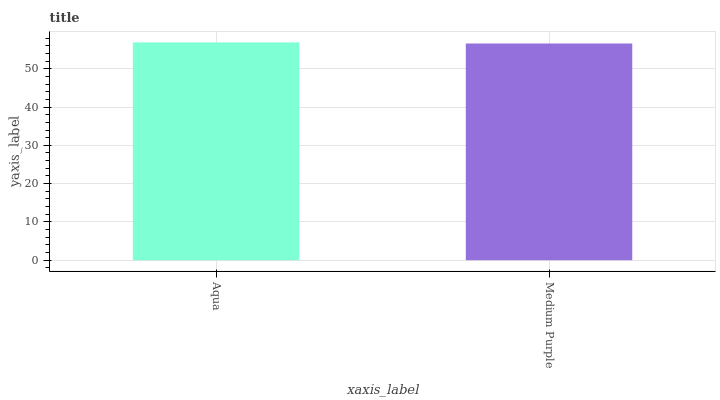Is Medium Purple the minimum?
Answer yes or no. Yes. Is Aqua the maximum?
Answer yes or no. Yes. Is Medium Purple the maximum?
Answer yes or no. No. Is Aqua greater than Medium Purple?
Answer yes or no. Yes. Is Medium Purple less than Aqua?
Answer yes or no. Yes. Is Medium Purple greater than Aqua?
Answer yes or no. No. Is Aqua less than Medium Purple?
Answer yes or no. No. Is Aqua the high median?
Answer yes or no. Yes. Is Medium Purple the low median?
Answer yes or no. Yes. Is Medium Purple the high median?
Answer yes or no. No. Is Aqua the low median?
Answer yes or no. No. 